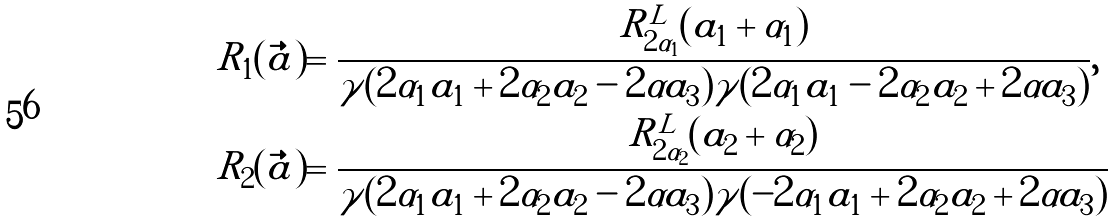<formula> <loc_0><loc_0><loc_500><loc_500>& R _ { 1 } ( \vec { a } ) = \frac { R _ { 2 \alpha _ { 1 } } ^ { L } ( a _ { 1 } + \alpha _ { 1 } ) } { \gamma ( 2 \alpha _ { 1 } a _ { 1 } + 2 \alpha _ { 2 } a _ { 2 } - 2 \alpha a _ { 3 } ) \gamma ( 2 \alpha _ { 1 } a _ { 1 } - 2 \alpha _ { 2 } a _ { 2 } + 2 \alpha a _ { 3 } ) } , \\ & R _ { 2 } ( \vec { a } ) = \frac { R _ { 2 \alpha _ { 2 } } ^ { L } ( a _ { 2 } + \alpha _ { 2 } ) } { \gamma ( 2 \alpha _ { 1 } a _ { 1 } + 2 \alpha _ { 2 } a _ { 2 } - 2 \alpha a _ { 3 } ) \gamma ( - 2 \alpha _ { 1 } a _ { 1 } + 2 \alpha _ { 2 } a _ { 2 } + 2 \alpha a _ { 3 } ) }</formula> 